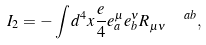Convert formula to latex. <formula><loc_0><loc_0><loc_500><loc_500>I _ { 2 } = - \int d ^ { 4 } x \frac { e } { 4 } e _ { a } ^ { \mu } e _ { b } ^ { \nu } R _ { \mu \nu } ^ { \quad a b } ,</formula> 